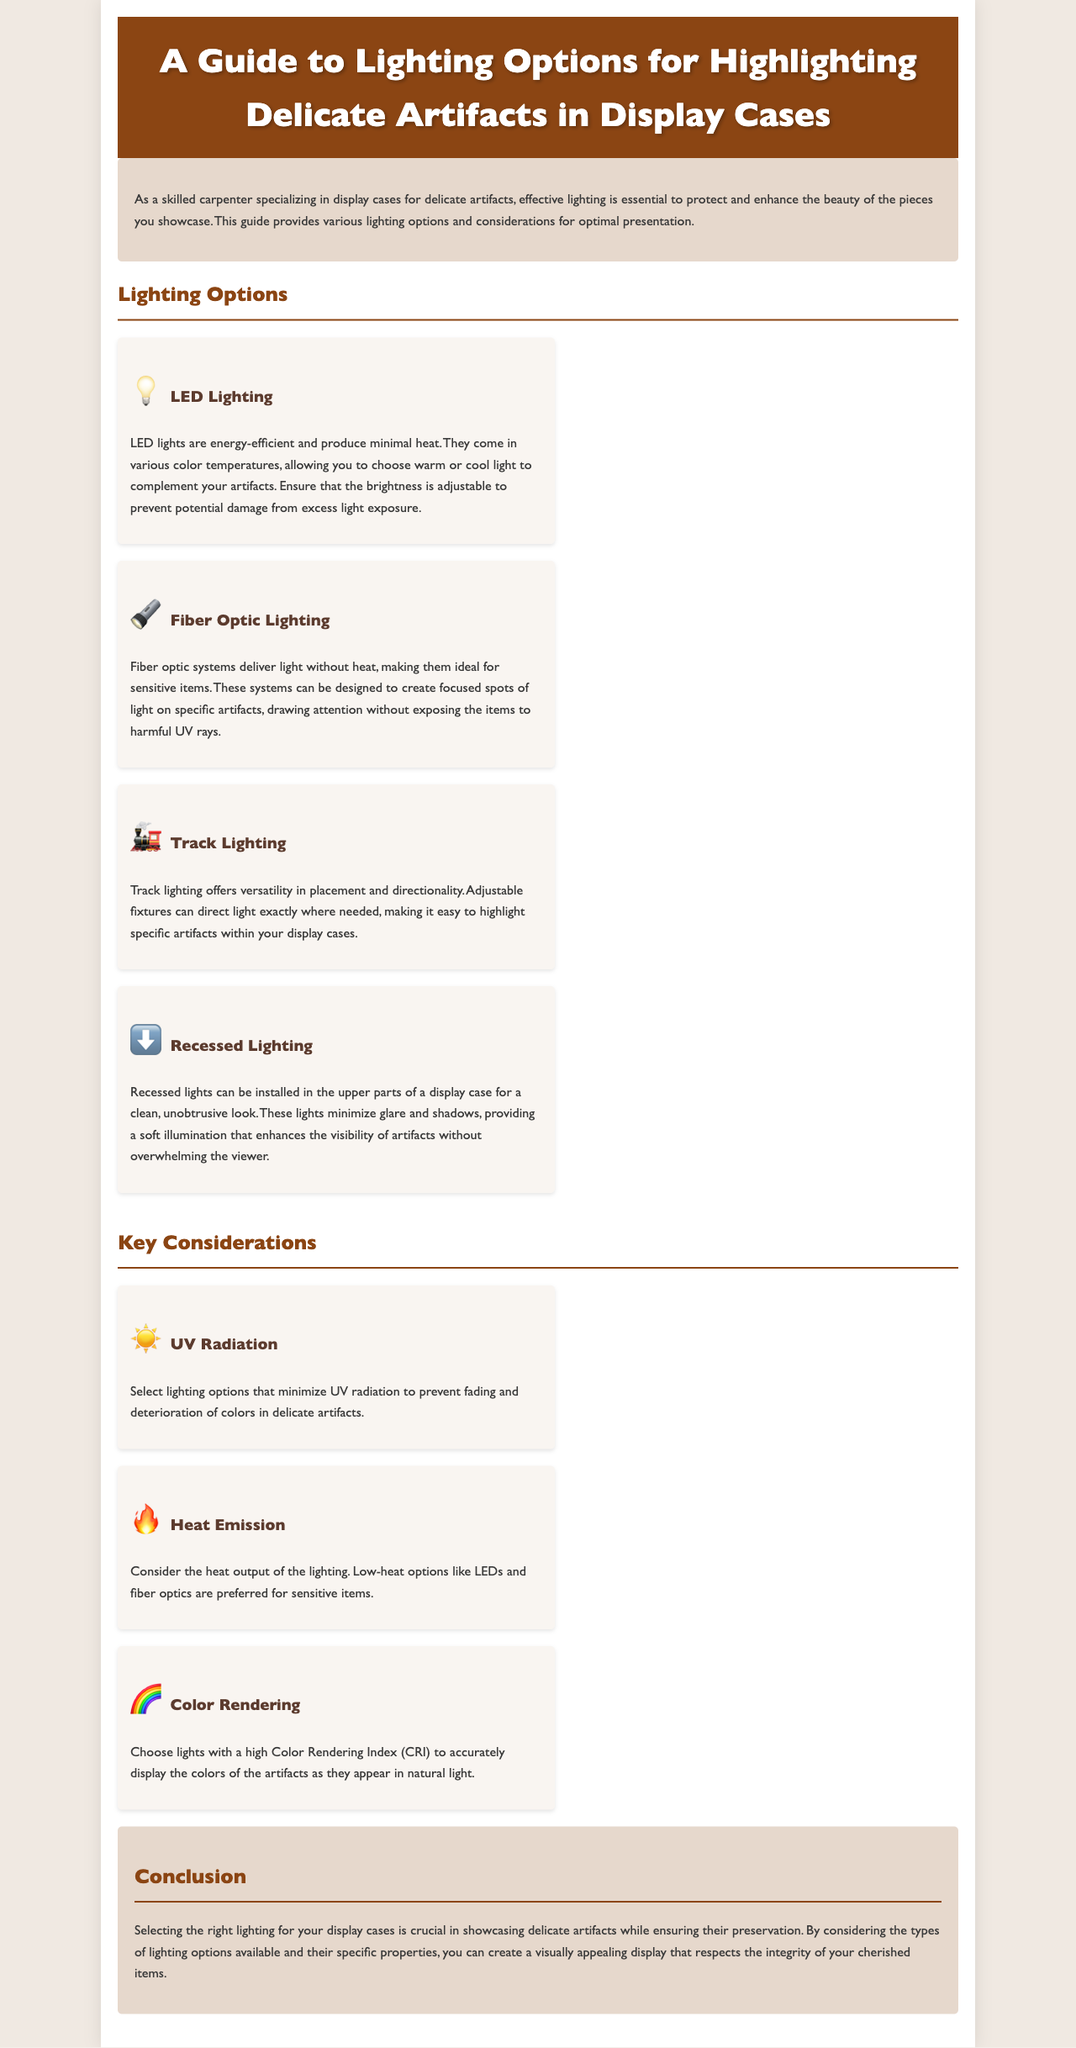What is the title of the brochure? The title of the brochure is prominently displayed at the top of the document.
Answer: A Guide to Lighting Options for Highlighting Delicate Artifacts in Display Cases What lighting option produces minimal heat? This information can be found in the descriptions of the lighting options.
Answer: LED Lighting Which lighting option allows for focused spots of light? The description highlights the unique ability of this lighting option in the context of displaying artifacts.
Answer: Fiber Optic Lighting What should be minimized to prevent fading of artifacts? The document specifically mentions an aspect of lighting that affects artifacts negatively.
Answer: UV Radiation Which lighting option provides a clean look? The text describes a lighting option that is specifically noted for its unobtrusive design.
Answer: Recessed Lighting What should you consider regarding heat emission? Considerations for lighting options include various factors that affect delicate artifacts.
Answer: Low-heat options What does CRI stand for? The document touches on an aspect important for accurately displaying colors.
Answer: Color Rendering Index How many lighting options are listed in the brochure? The document enumerates different lighting types, providing a distinct count.
Answer: Four What is the maximum width of the container for the brochure? The size related to the layout of the document is specified in the style section.
Answer: 1000px 